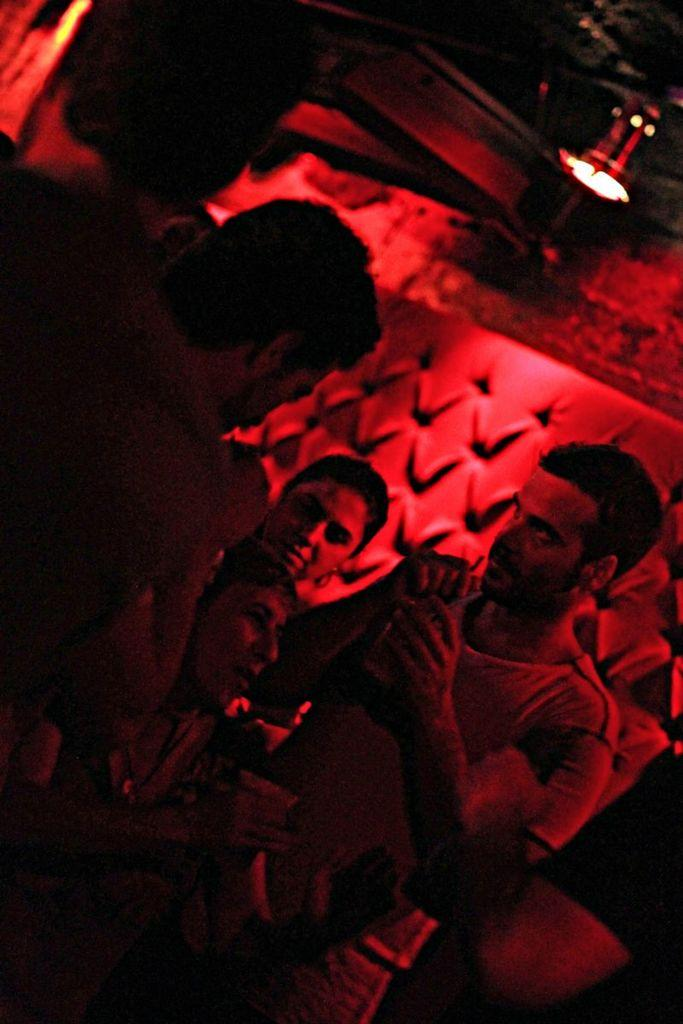Who or what can be seen in the image? There are people in the image. What is the background of the image? There is a wall in the image. Can you describe the lighting in the image? There is light visible in the image. What type of hook can be seen hanging from the wall in the image? There is no hook visible in the image; only people and a wall are present. 